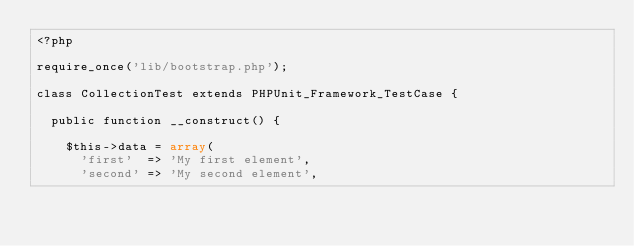Convert code to text. <code><loc_0><loc_0><loc_500><loc_500><_PHP_><?php

require_once('lib/bootstrap.php');

class CollectionTest extends PHPUnit_Framework_TestCase {
  
  public function __construct() {
  
    $this->data = array(
      'first'  => 'My first element',
      'second' => 'My second element',</code> 